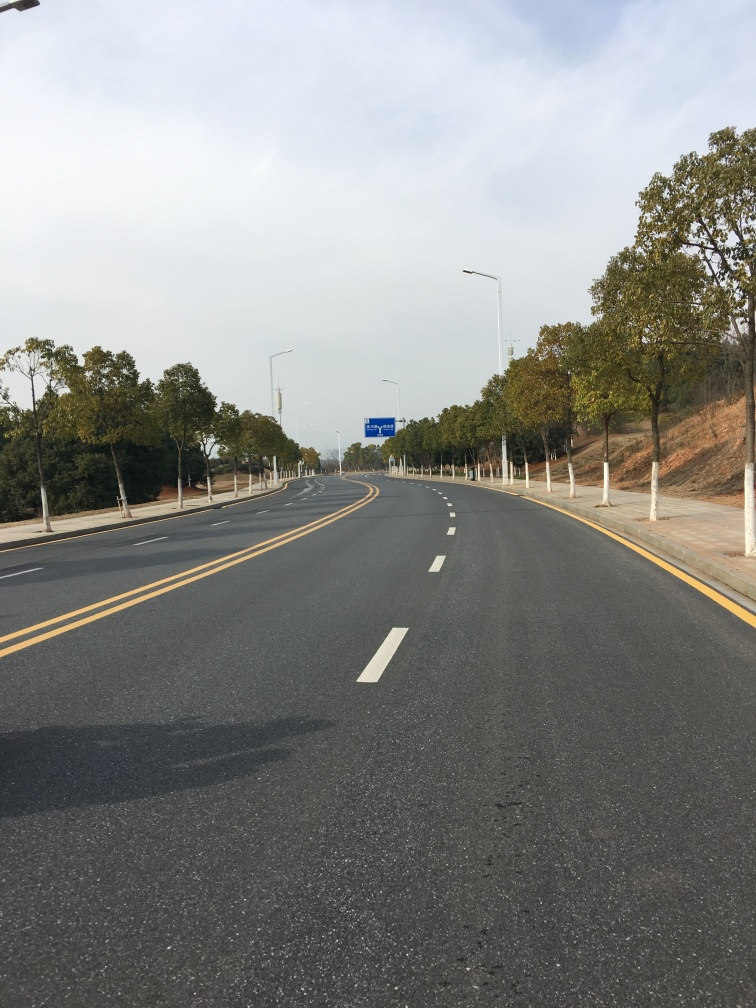How does this road look in terms of traffic? The road appears to be free from traffic, offering a clear path ahead. The lanes are empty and no vehicles can be seen, suggesting a peaceful drive with no congestion at this moment. 